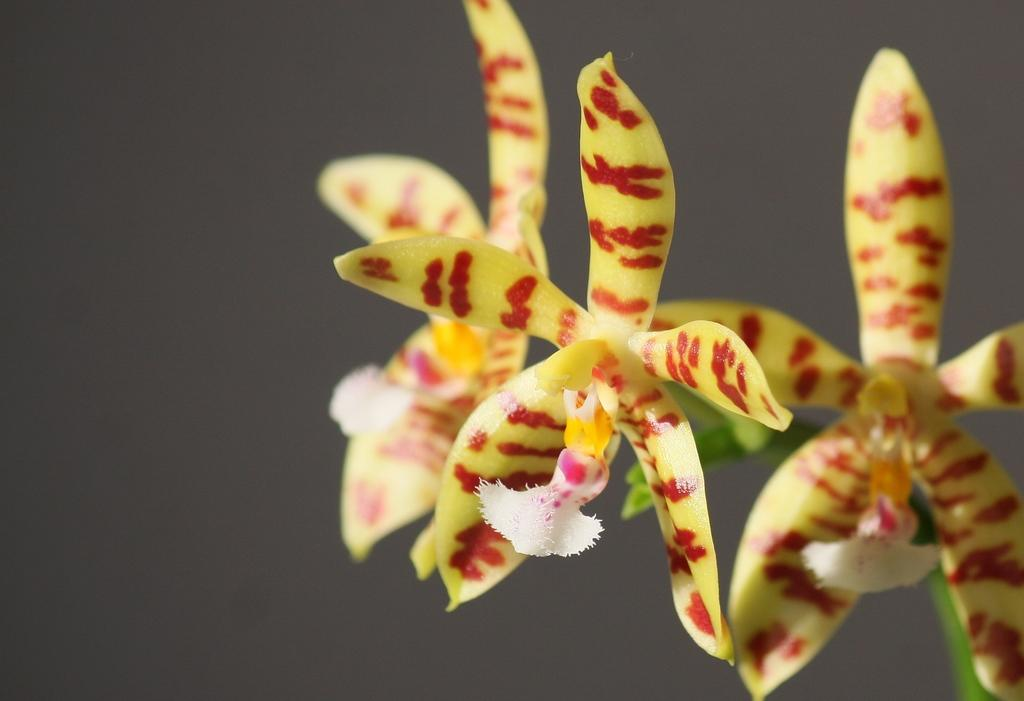What type of flowers can be seen in the image? There are yellow color flowers in the image. Can you tell me how many times the flowers jump in the image? There is no indication of the flowers jumping in the image, as flowers do not have the ability to jump. 